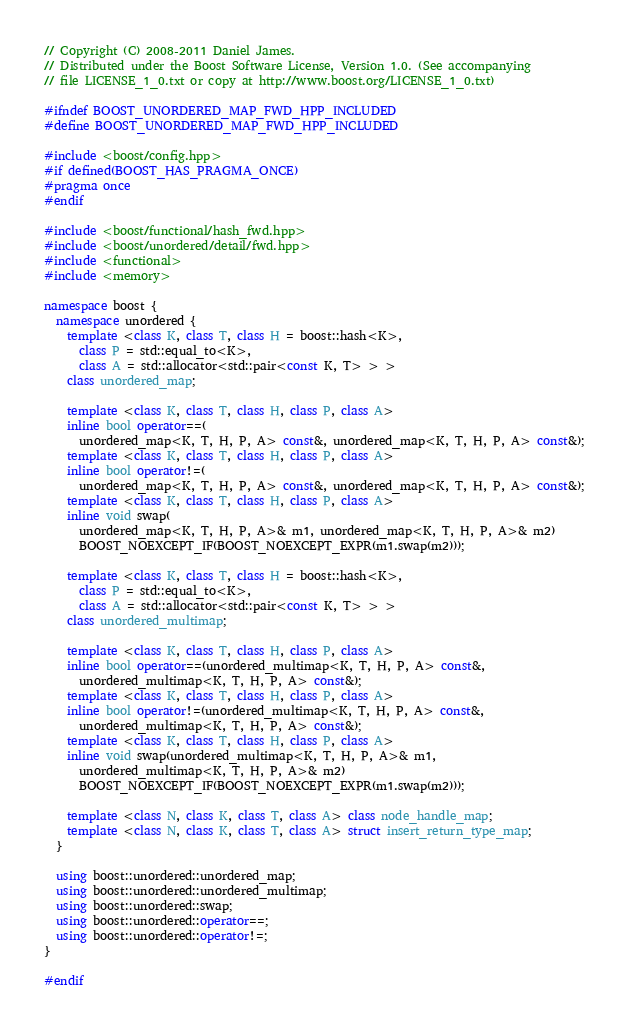<code> <loc_0><loc_0><loc_500><loc_500><_C++_>
// Copyright (C) 2008-2011 Daniel James.
// Distributed under the Boost Software License, Version 1.0. (See accompanying
// file LICENSE_1_0.txt or copy at http://www.boost.org/LICENSE_1_0.txt)

#ifndef BOOST_UNORDERED_MAP_FWD_HPP_INCLUDED
#define BOOST_UNORDERED_MAP_FWD_HPP_INCLUDED

#include <boost/config.hpp>
#if defined(BOOST_HAS_PRAGMA_ONCE)
#pragma once
#endif

#include <boost/functional/hash_fwd.hpp>
#include <boost/unordered/detail/fwd.hpp>
#include <functional>
#include <memory>

namespace boost {
  namespace unordered {
    template <class K, class T, class H = boost::hash<K>,
      class P = std::equal_to<K>,
      class A = std::allocator<std::pair<const K, T> > >
    class unordered_map;

    template <class K, class T, class H, class P, class A>
    inline bool operator==(
      unordered_map<K, T, H, P, A> const&, unordered_map<K, T, H, P, A> const&);
    template <class K, class T, class H, class P, class A>
    inline bool operator!=(
      unordered_map<K, T, H, P, A> const&, unordered_map<K, T, H, P, A> const&);
    template <class K, class T, class H, class P, class A>
    inline void swap(
      unordered_map<K, T, H, P, A>& m1, unordered_map<K, T, H, P, A>& m2)
      BOOST_NOEXCEPT_IF(BOOST_NOEXCEPT_EXPR(m1.swap(m2)));

    template <class K, class T, class H = boost::hash<K>,
      class P = std::equal_to<K>,
      class A = std::allocator<std::pair<const K, T> > >
    class unordered_multimap;

    template <class K, class T, class H, class P, class A>
    inline bool operator==(unordered_multimap<K, T, H, P, A> const&,
      unordered_multimap<K, T, H, P, A> const&);
    template <class K, class T, class H, class P, class A>
    inline bool operator!=(unordered_multimap<K, T, H, P, A> const&,
      unordered_multimap<K, T, H, P, A> const&);
    template <class K, class T, class H, class P, class A>
    inline void swap(unordered_multimap<K, T, H, P, A>& m1,
      unordered_multimap<K, T, H, P, A>& m2)
      BOOST_NOEXCEPT_IF(BOOST_NOEXCEPT_EXPR(m1.swap(m2)));

    template <class N, class K, class T, class A> class node_handle_map;
    template <class N, class K, class T, class A> struct insert_return_type_map;
  }

  using boost::unordered::unordered_map;
  using boost::unordered::unordered_multimap;
  using boost::unordered::swap;
  using boost::unordered::operator==;
  using boost::unordered::operator!=;
}

#endif
</code> 